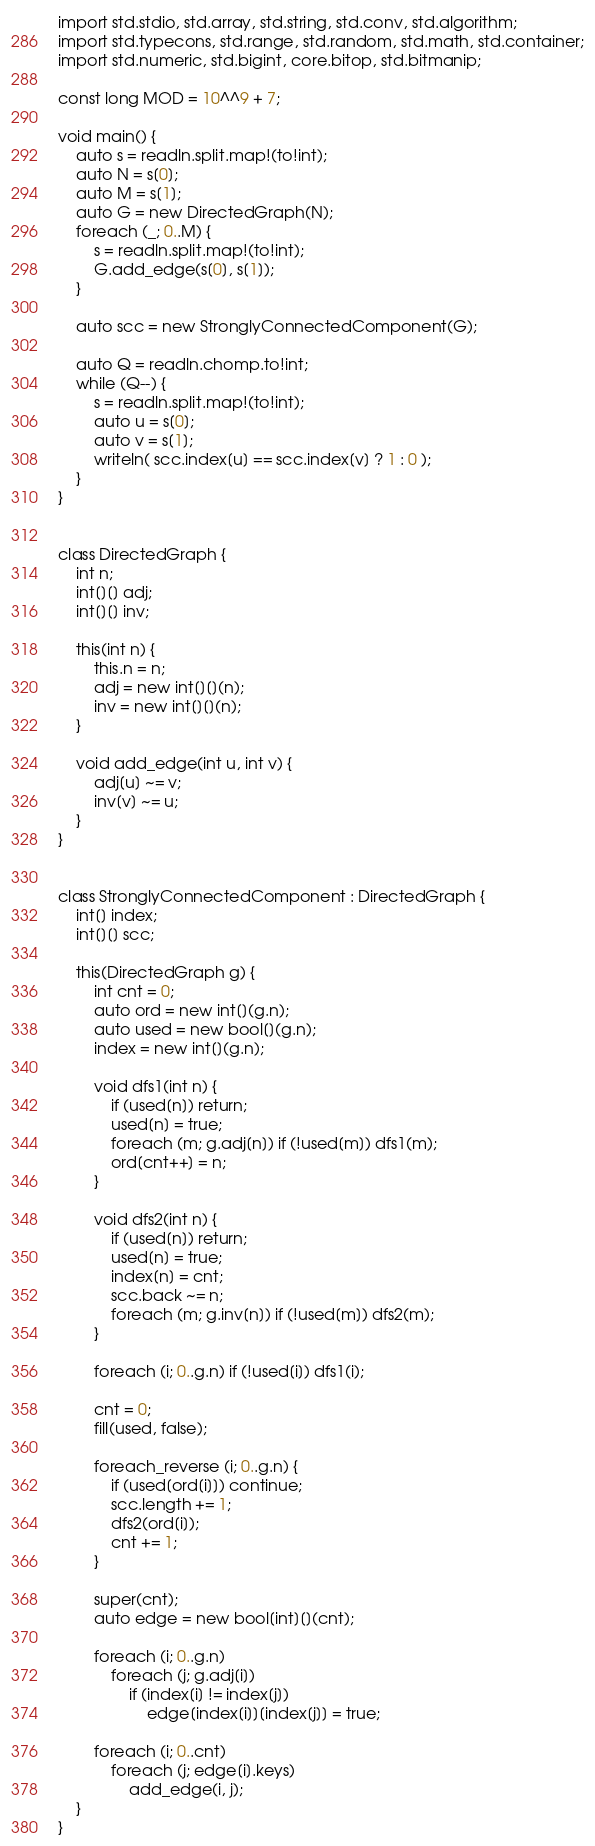<code> <loc_0><loc_0><loc_500><loc_500><_D_>import std.stdio, std.array, std.string, std.conv, std.algorithm;
import std.typecons, std.range, std.random, std.math, std.container;
import std.numeric, std.bigint, core.bitop, std.bitmanip;

const long MOD = 10^^9 + 7;

void main() {
    auto s = readln.split.map!(to!int);
    auto N = s[0];
    auto M = s[1];
    auto G = new DirectedGraph(N);
    foreach (_; 0..M) {
        s = readln.split.map!(to!int);
        G.add_edge(s[0], s[1]);
    }

    auto scc = new StronglyConnectedComponent(G);

    auto Q = readln.chomp.to!int;
    while (Q--) {
        s = readln.split.map!(to!int);
        auto u = s[0];
        auto v = s[1];
        writeln( scc.index[u] == scc.index[v] ? 1 : 0 );
    }
}


class DirectedGraph {
    int n;
    int[][] adj;
    int[][] inv;

    this(int n) {
        this.n = n;
        adj = new int[][](n);
        inv = new int[][](n);
    }

    void add_edge(int u, int v) {
        adj[u] ~= v;
        inv[v] ~= u;
    }
}


class StronglyConnectedComponent : DirectedGraph {
    int[] index;
    int[][] scc;

    this(DirectedGraph g) {
        int cnt = 0;
        auto ord = new int[](g.n);
        auto used = new bool[](g.n);
        index = new int[](g.n);

        void dfs1(int n) {
            if (used[n]) return;
            used[n] = true;
            foreach (m; g.adj[n]) if (!used[m]) dfs1(m);
            ord[cnt++] = n;
        }

        void dfs2(int n) {
            if (used[n]) return;
            used[n] = true;
            index[n] = cnt;
            scc.back ~= n;
            foreach (m; g.inv[n]) if (!used[m]) dfs2(m);
        }

        foreach (i; 0..g.n) if (!used[i]) dfs1(i);

        cnt = 0;
        fill(used, false);

        foreach_reverse (i; 0..g.n) {
            if (used[ord[i]]) continue;
            scc.length += 1;
            dfs2(ord[i]);
            cnt += 1;
        }

        super(cnt);
        auto edge = new bool[int][](cnt);

        foreach (i; 0..g.n)
            foreach (j; g.adj[i])
                if (index[i] != index[j])
                    edge[index[i]][index[j]] = true;

        foreach (i; 0..cnt)
            foreach (j; edge[i].keys)
                add_edge(i, j);
    }
}

</code> 